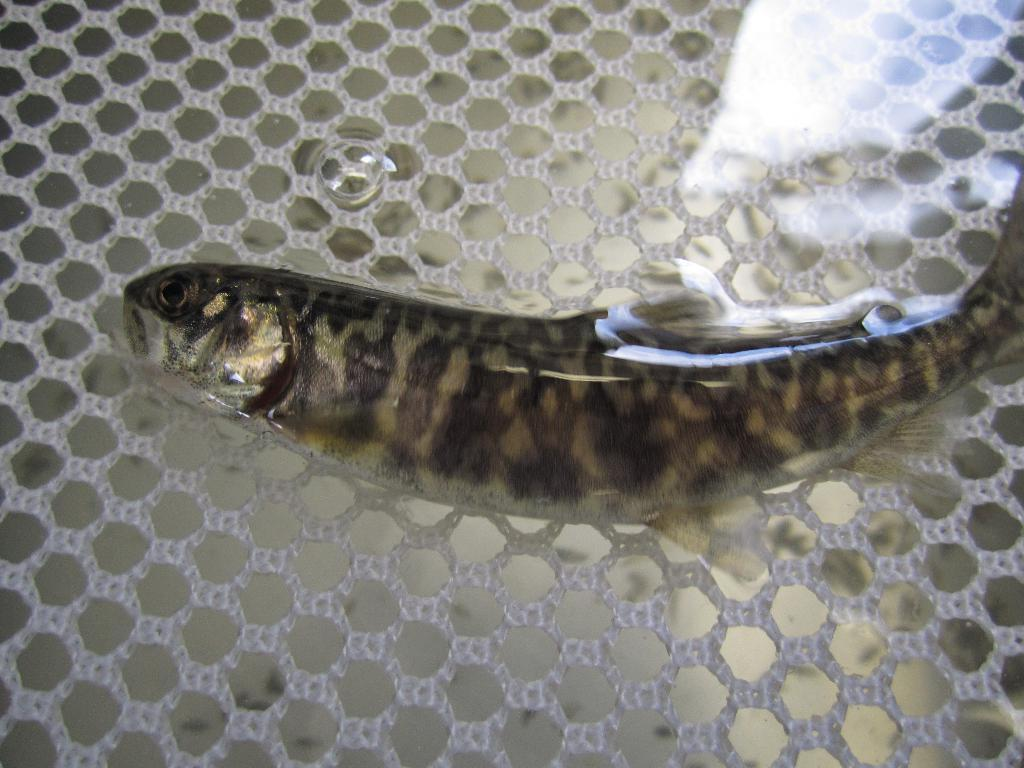What type of animal can be seen in the image? There is a fish in the water in the image. Can you describe the environment in which the fish is located? The fish is located in water in the image. What type of flowers can be seen growing near the fish in the image? There are no flowers present in the image; it features a fish in water. What type of beef dish is being prepared in the image? There is no beef or any food preparation visible in the image; it features a fish in water. 